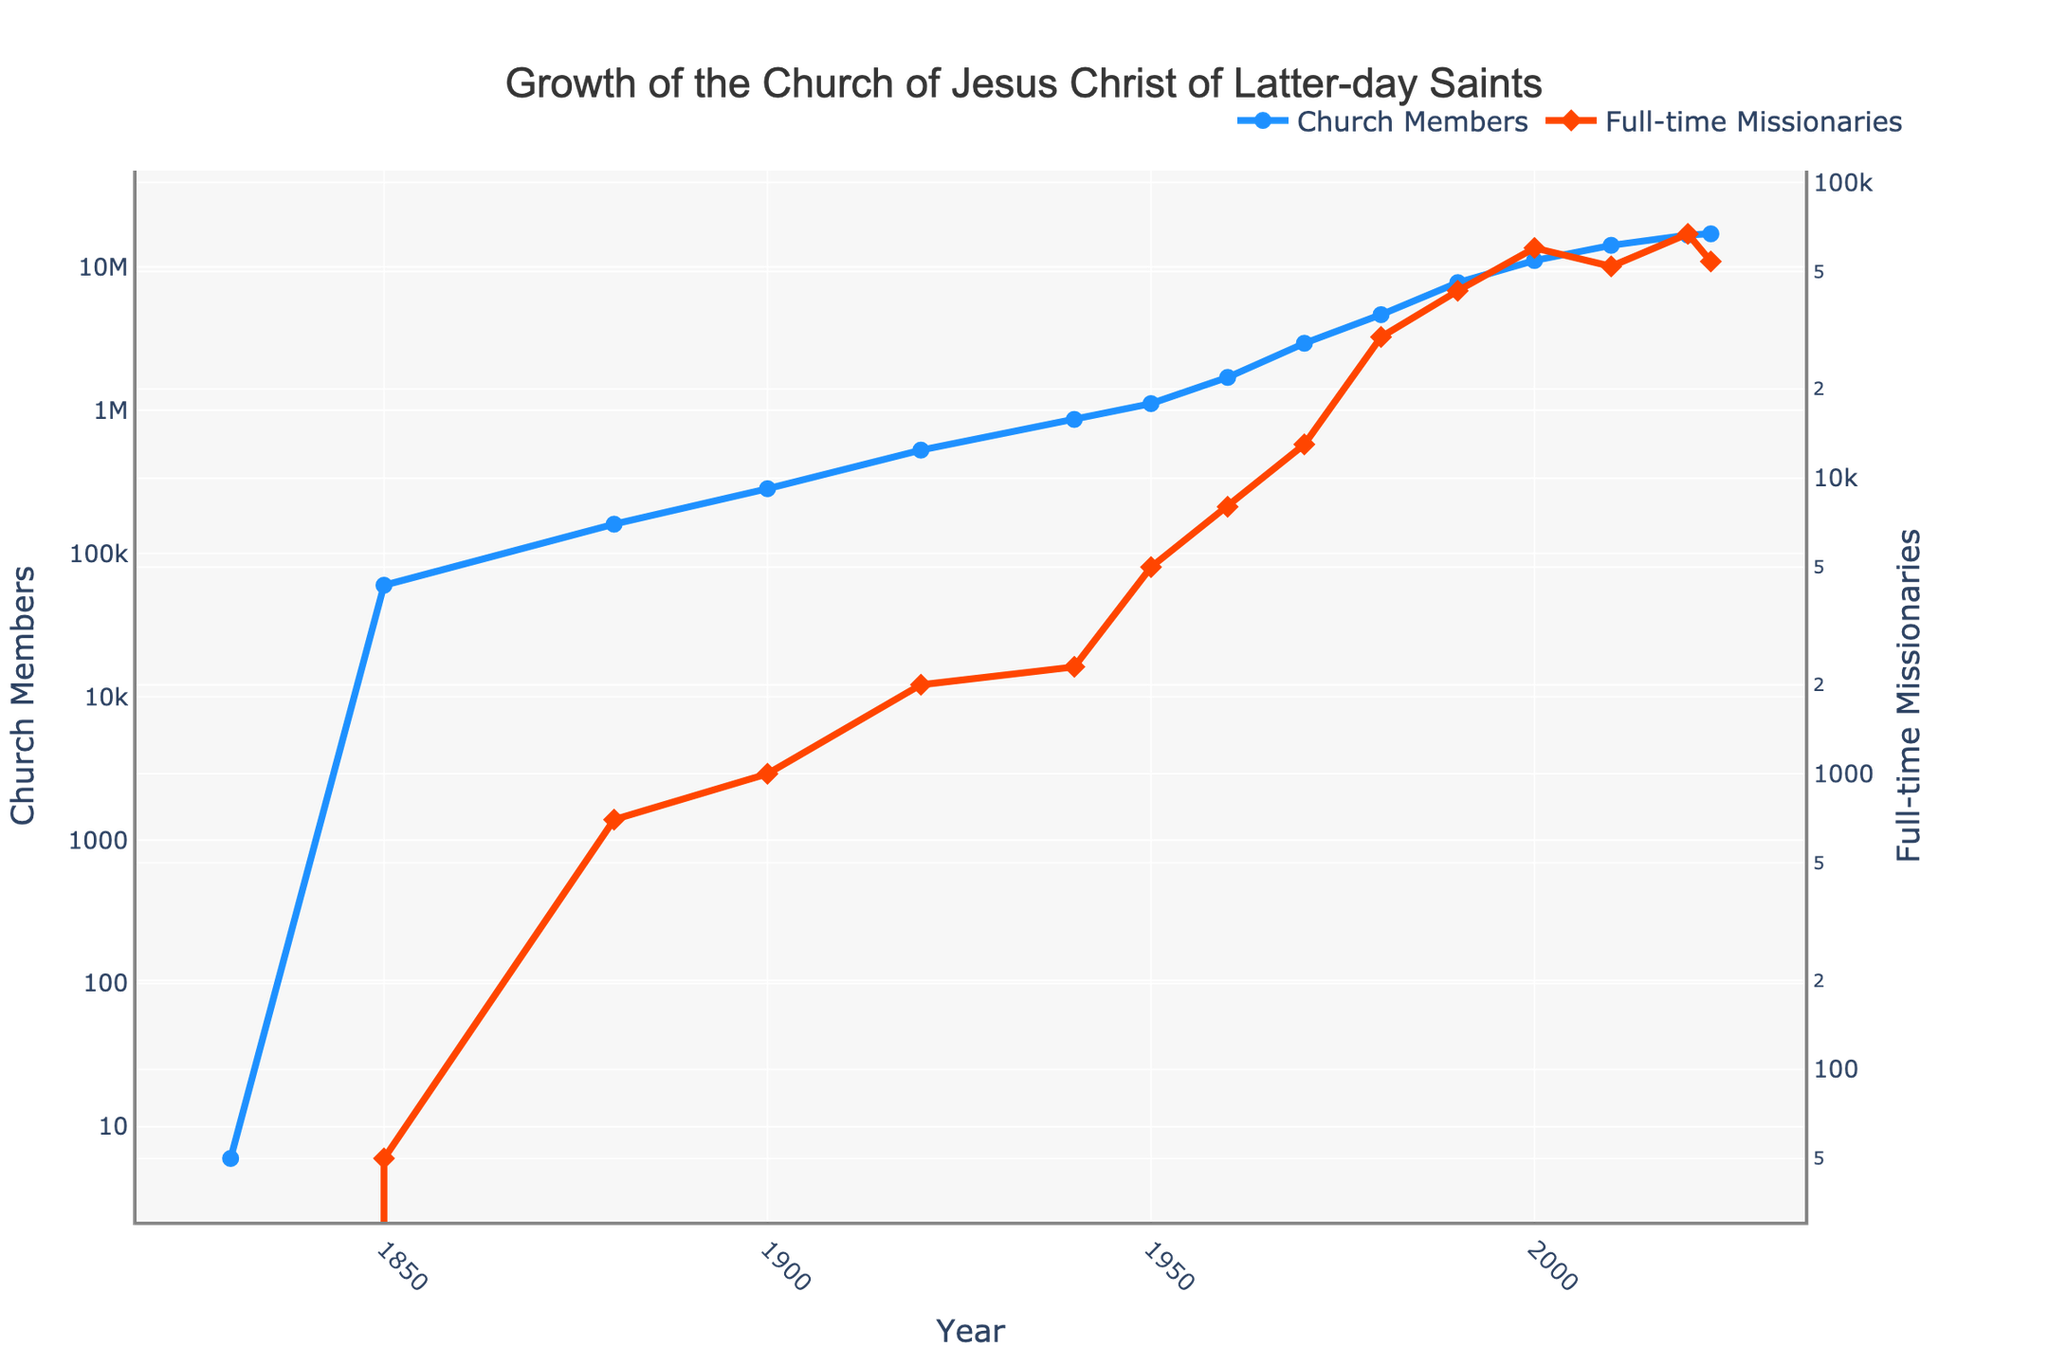What was the number of Church Members in 1980? Locate the point in the line representing "Church Members" in 1980 and read the y-axis value corresponding to that point. This point is marked with a blue circle.
Answer: 4,639,000 How many more missionaries were there in 2020 compared to 1990? Find the y-values for "Full-time Missionaries" in both 2020 and 1990 from the red diamonds, then subtract the 1990 value from the 2020 value (67,000 - 43,000 = 24,000).
Answer: 24,000 What is the average number of Church Members from 1880 to 1920? Sum the Church Members for the years 1880, 1900, and 1920 (160,000 + 283,000 + 526,000 = 969,000), then divide by the number of years (3).
Answer: 323,000 Which year had the highest number of Full-time Missionaries, and what was the number? Examine the points representing "Full-time Missionaries" and identify the highest value, which occurs at the red diamond in the year 2020.
Answer: 2020, 67,000 How did the number of Church Members change between 1940 and 1950? Find the y-values for "Church Members" in 1940 and 1950, then subtract the 1940 value from the 1950 value (1,111,000 - 862,000 = 249,000)
Answer: Increased by 249,000 In what year did the number of Church Members first exceed 10 million? Scan the line chart representing "Church Members" to find the year when the value crosses 10 million. This occurs around the year 2000.
Answer: 2000 Which had more growth between 1970 and 1980, Church Members or Full-time Missionaries? Calculate the change for both: Church Members: 4,639,000 - 2,930,000 = 1,709,000, Full-time Missionaries: 30,000 - 13,000 = 17,000. Compare the magnitudes.
Answer: Church Members From 1830 to 2023, during which decade did Full-time Missionaries experience their largest increase? Calculate the differences per decade and identify the largest: 1950-1960: 8,000 - 5,000 = 3,000, 1960-1970: 13,000 - 8,000 = 5,000, etc. The largest increase occurs from 1970-1980.
Answer: 1970-1980 How did the number of Full-time Missionaries change between 2000 and 2010? Subtract the y-value for "Full-time Missionaries" in 2000 from the y-value in 2010 (52,000 - 60,000 = -8,000).
Answer: Decreased by 8,000 